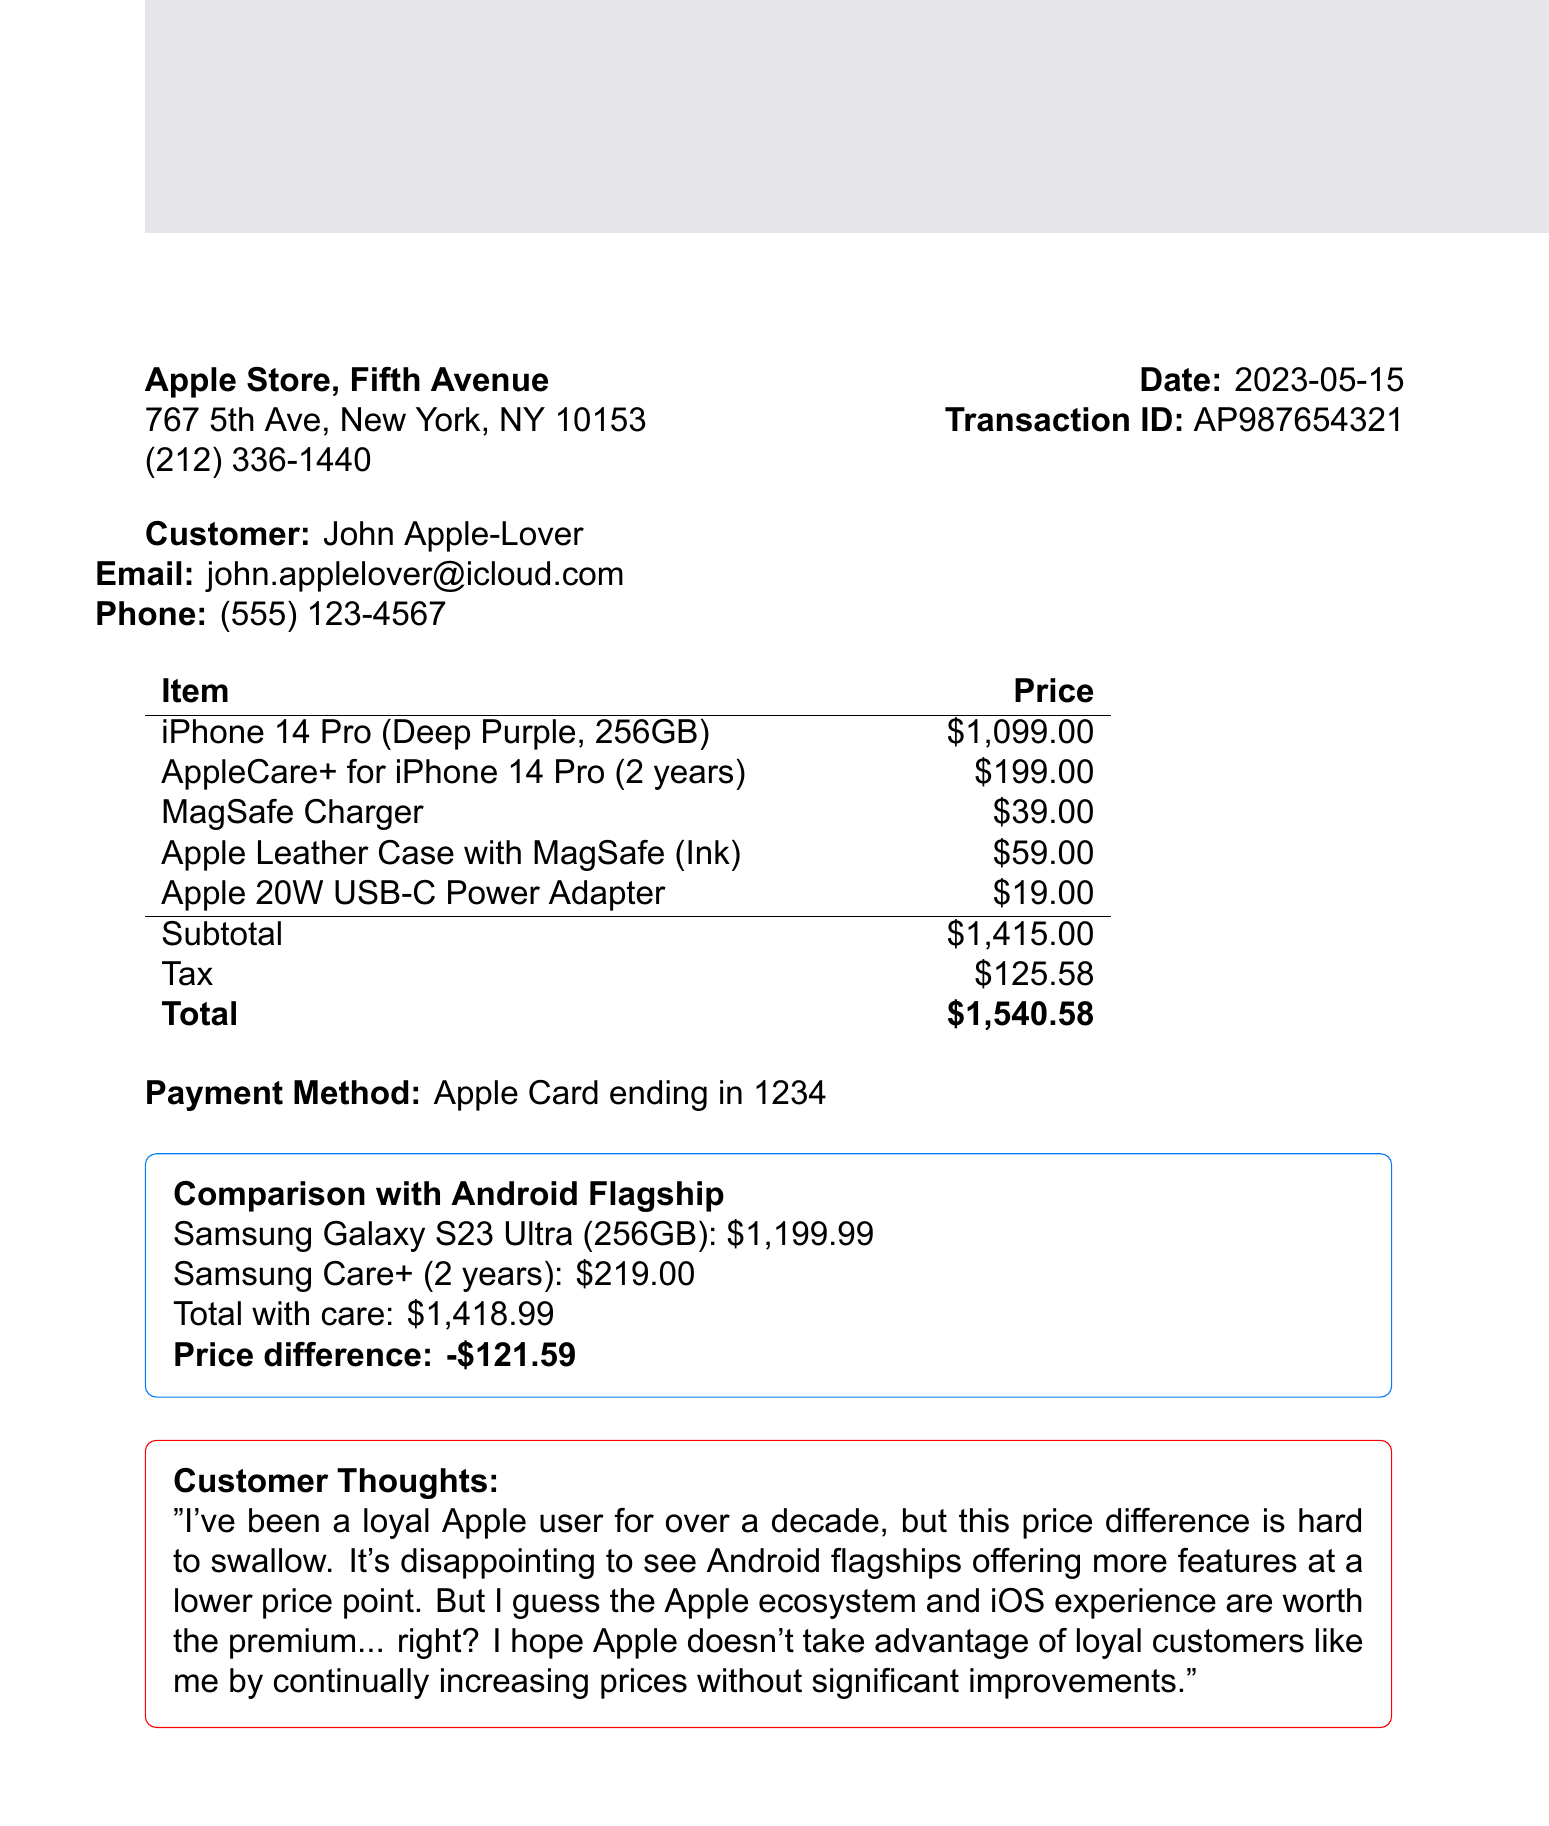What is the purchase date? The purchase date is explicitly mentioned in the document under the transaction details.
Answer: 2023-05-15 What was the total price of the transaction? The total price is stated at the end of the receipt, summing the items and tax.
Answer: $1,540.58 What storage capacity does the iPhone 14 Pro have? The document specifies the storage capacity of the purchased iPhone 14 Pro in the item description.
Answer: 256GB What is the duration of the AppleCare+ plan? The duration of the AppleCare+ plan is included in the item description for AppleCare+.
Answer: 2 years What is the price difference between iPhone 14 Pro and Samsung Galaxy S23 Ultra with care? The price difference is calculated based on the total costs provided for both devices including care plans.
Answer: -$121.59 What accessory has the highest price? The prices of all accessories are listed, allowing for a comparison to determine the highest-priced item.
Answer: AppleCare+ for iPhone 14 Pro How many items were listed in the purchase? The number of items can be counted from the list provided in the document under the purchased items section.
Answer: 5 What payment method was used for the transaction? The payment method is mentioned clearly in the document, indicating how the purchase was settled.
Answer: Apple Card What color is the Apple Leather Case? The color of the Apple Leather Case is explicitly stated in the item description.
Answer: Ink What is the name of the store where the purchase was made? The store name is provided at the top of the transaction document.
Answer: Apple Store, Fifth Avenue 